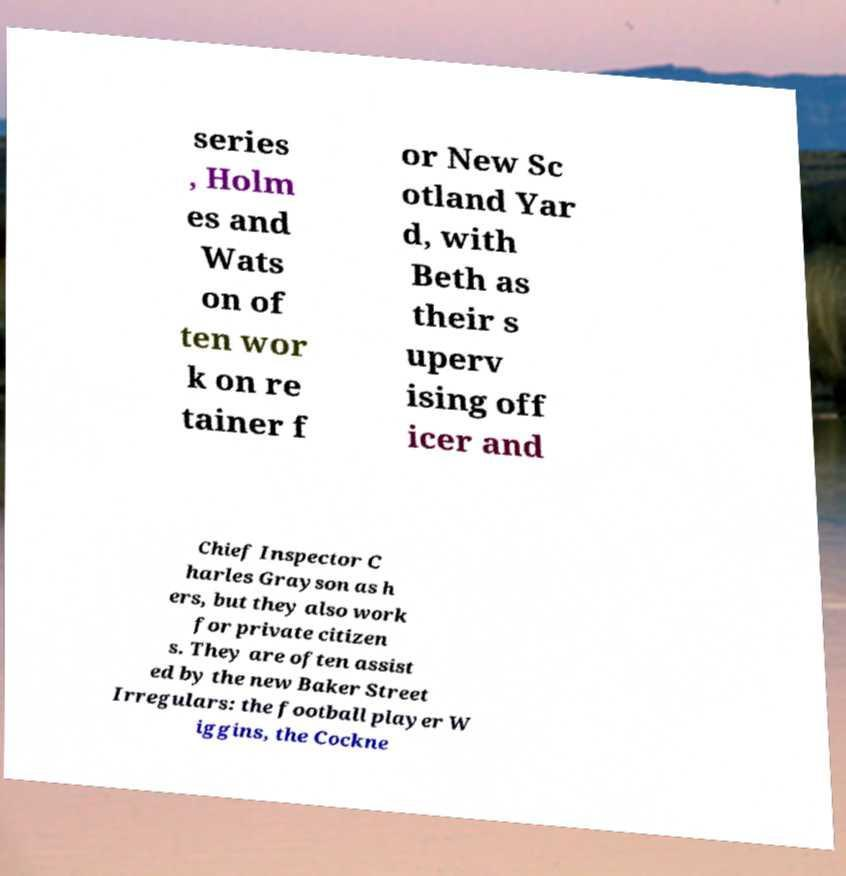There's text embedded in this image that I need extracted. Can you transcribe it verbatim? series , Holm es and Wats on of ten wor k on re tainer f or New Sc otland Yar d, with Beth as their s uperv ising off icer and Chief Inspector C harles Grayson as h ers, but they also work for private citizen s. They are often assist ed by the new Baker Street Irregulars: the football player W iggins, the Cockne 